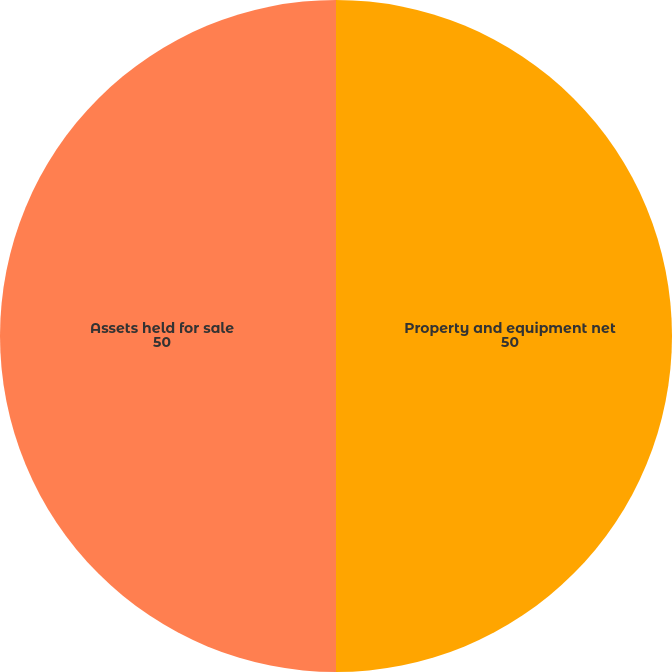Convert chart to OTSL. <chart><loc_0><loc_0><loc_500><loc_500><pie_chart><fcel>Property and equipment net<fcel>Assets held for sale<nl><fcel>50.0%<fcel>50.0%<nl></chart> 